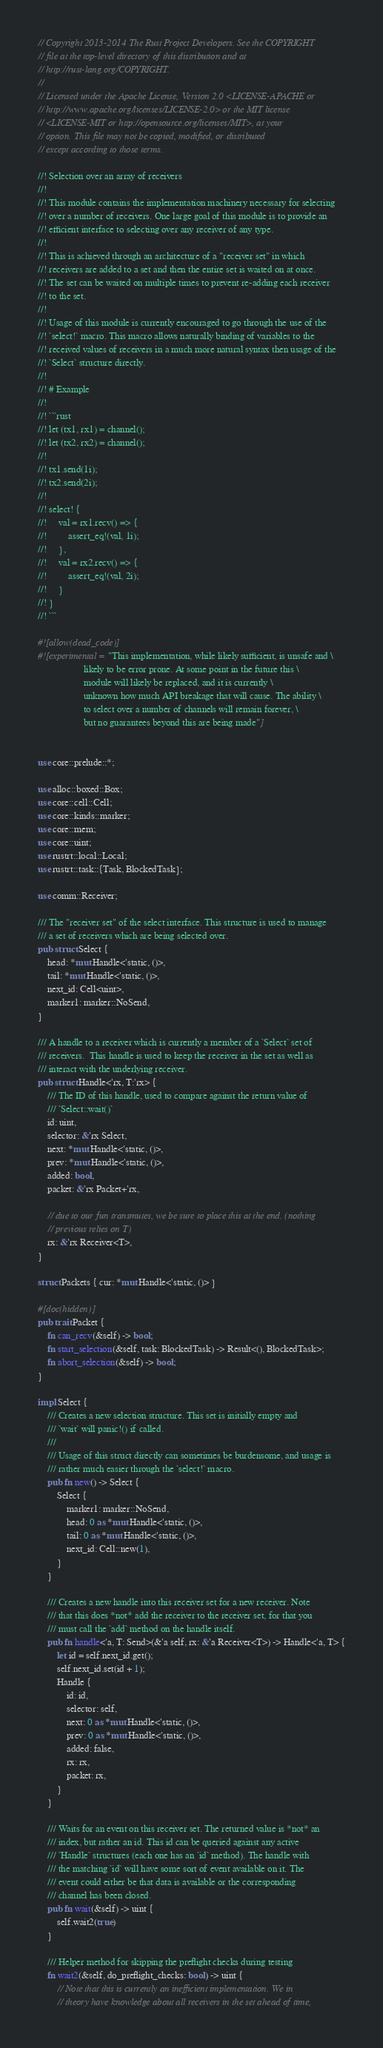Convert code to text. <code><loc_0><loc_0><loc_500><loc_500><_Rust_>// Copyright 2013-2014 The Rust Project Developers. See the COPYRIGHT
// file at the top-level directory of this distribution and at
// http://rust-lang.org/COPYRIGHT.
//
// Licensed under the Apache License, Version 2.0 <LICENSE-APACHE or
// http://www.apache.org/licenses/LICENSE-2.0> or the MIT license
// <LICENSE-MIT or http://opensource.org/licenses/MIT>, at your
// option. This file may not be copied, modified, or distributed
// except according to those terms.

//! Selection over an array of receivers
//!
//! This module contains the implementation machinery necessary for selecting
//! over a number of receivers. One large goal of this module is to provide an
//! efficient interface to selecting over any receiver of any type.
//!
//! This is achieved through an architecture of a "receiver set" in which
//! receivers are added to a set and then the entire set is waited on at once.
//! The set can be waited on multiple times to prevent re-adding each receiver
//! to the set.
//!
//! Usage of this module is currently encouraged to go through the use of the
//! `select!` macro. This macro allows naturally binding of variables to the
//! received values of receivers in a much more natural syntax then usage of the
//! `Select` structure directly.
//!
//! # Example
//!
//! ```rust
//! let (tx1, rx1) = channel();
//! let (tx2, rx2) = channel();
//!
//! tx1.send(1i);
//! tx2.send(2i);
//!
//! select! {
//!     val = rx1.recv() => {
//!         assert_eq!(val, 1i);
//!     },
//!     val = rx2.recv() => {
//!         assert_eq!(val, 2i);
//!     }
//! }
//! ```

#![allow(dead_code)]
#![experimental = "This implementation, while likely sufficient, is unsafe and \
                   likely to be error prone. At some point in the future this \
                   module will likely be replaced, and it is currently \
                   unknown how much API breakage that will cause. The ability \
                   to select over a number of channels will remain forever, \
                   but no guarantees beyond this are being made"]


use core::prelude::*;

use alloc::boxed::Box;
use core::cell::Cell;
use core::kinds::marker;
use core::mem;
use core::uint;
use rustrt::local::Local;
use rustrt::task::{Task, BlockedTask};

use comm::Receiver;

/// The "receiver set" of the select interface. This structure is used to manage
/// a set of receivers which are being selected over.
pub struct Select {
    head: *mut Handle<'static, ()>,
    tail: *mut Handle<'static, ()>,
    next_id: Cell<uint>,
    marker1: marker::NoSend,
}

/// A handle to a receiver which is currently a member of a `Select` set of
/// receivers.  This handle is used to keep the receiver in the set as well as
/// interact with the underlying receiver.
pub struct Handle<'rx, T:'rx> {
    /// The ID of this handle, used to compare against the return value of
    /// `Select::wait()`
    id: uint,
    selector: &'rx Select,
    next: *mut Handle<'static, ()>,
    prev: *mut Handle<'static, ()>,
    added: bool,
    packet: &'rx Packet+'rx,

    // due to our fun transmutes, we be sure to place this at the end. (nothing
    // previous relies on T)
    rx: &'rx Receiver<T>,
}

struct Packets { cur: *mut Handle<'static, ()> }

#[doc(hidden)]
pub trait Packet {
    fn can_recv(&self) -> bool;
    fn start_selection(&self, task: BlockedTask) -> Result<(), BlockedTask>;
    fn abort_selection(&self) -> bool;
}

impl Select {
    /// Creates a new selection structure. This set is initially empty and
    /// `wait` will panic!() if called.
    ///
    /// Usage of this struct directly can sometimes be burdensome, and usage is
    /// rather much easier through the `select!` macro.
    pub fn new() -> Select {
        Select {
            marker1: marker::NoSend,
            head: 0 as *mut Handle<'static, ()>,
            tail: 0 as *mut Handle<'static, ()>,
            next_id: Cell::new(1),
        }
    }

    /// Creates a new handle into this receiver set for a new receiver. Note
    /// that this does *not* add the receiver to the receiver set, for that you
    /// must call the `add` method on the handle itself.
    pub fn handle<'a, T: Send>(&'a self, rx: &'a Receiver<T>) -> Handle<'a, T> {
        let id = self.next_id.get();
        self.next_id.set(id + 1);
        Handle {
            id: id,
            selector: self,
            next: 0 as *mut Handle<'static, ()>,
            prev: 0 as *mut Handle<'static, ()>,
            added: false,
            rx: rx,
            packet: rx,
        }
    }

    /// Waits for an event on this receiver set. The returned value is *not* an
    /// index, but rather an id. This id can be queried against any active
    /// `Handle` structures (each one has an `id` method). The handle with
    /// the matching `id` will have some sort of event available on it. The
    /// event could either be that data is available or the corresponding
    /// channel has been closed.
    pub fn wait(&self) -> uint {
        self.wait2(true)
    }

    /// Helper method for skipping the preflight checks during testing
    fn wait2(&self, do_preflight_checks: bool) -> uint {
        // Note that this is currently an inefficient implementation. We in
        // theory have knowledge about all receivers in the set ahead of time,</code> 